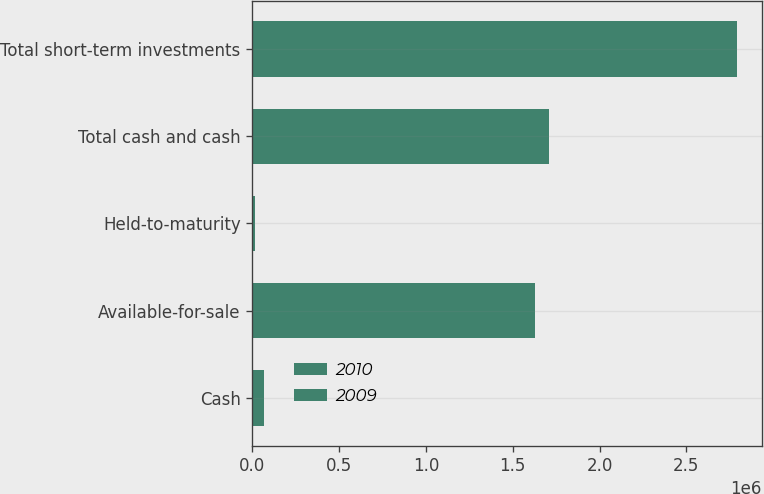Convert chart. <chart><loc_0><loc_0><loc_500><loc_500><stacked_bar_chart><ecel><fcel>Cash<fcel>Available-for-sale<fcel>Held-to-maturity<fcel>Total cash and cash<fcel>Total short-term investments<nl><fcel>2010<fcel>37460<fcel>1.02099e+06<fcel>11547<fcel>1.07e+06<fcel>1.61777e+06<nl><fcel>2009<fcel>30744<fcel>604276<fcel>4709<fcel>639729<fcel>1.17624e+06<nl></chart> 